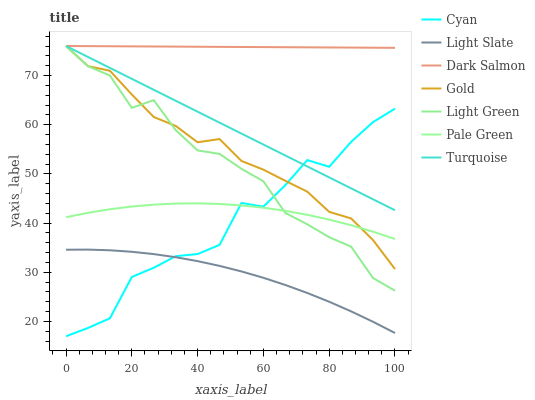Does Light Slate have the minimum area under the curve?
Answer yes or no. Yes. Does Dark Salmon have the maximum area under the curve?
Answer yes or no. Yes. Does Gold have the minimum area under the curve?
Answer yes or no. No. Does Gold have the maximum area under the curve?
Answer yes or no. No. Is Turquoise the smoothest?
Answer yes or no. Yes. Is Cyan the roughest?
Answer yes or no. Yes. Is Gold the smoothest?
Answer yes or no. No. Is Gold the roughest?
Answer yes or no. No. Does Cyan have the lowest value?
Answer yes or no. Yes. Does Gold have the lowest value?
Answer yes or no. No. Does Light Green have the highest value?
Answer yes or no. Yes. Does Light Slate have the highest value?
Answer yes or no. No. Is Light Slate less than Dark Salmon?
Answer yes or no. Yes. Is Dark Salmon greater than Pale Green?
Answer yes or no. Yes. Does Turquoise intersect Light Green?
Answer yes or no. Yes. Is Turquoise less than Light Green?
Answer yes or no. No. Is Turquoise greater than Light Green?
Answer yes or no. No. Does Light Slate intersect Dark Salmon?
Answer yes or no. No. 